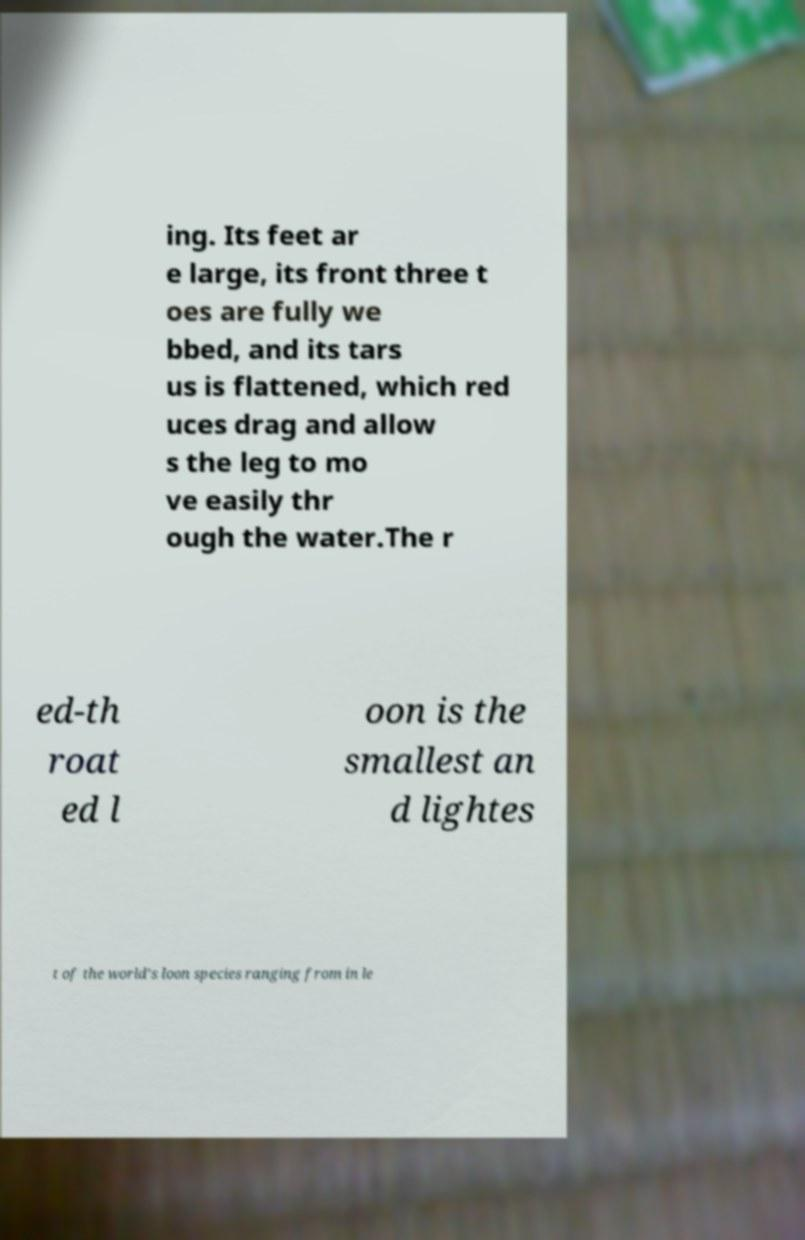Can you accurately transcribe the text from the provided image for me? ing. Its feet ar e large, its front three t oes are fully we bbed, and its tars us is flattened, which red uces drag and allow s the leg to mo ve easily thr ough the water.The r ed-th roat ed l oon is the smallest an d lightes t of the world's loon species ranging from in le 